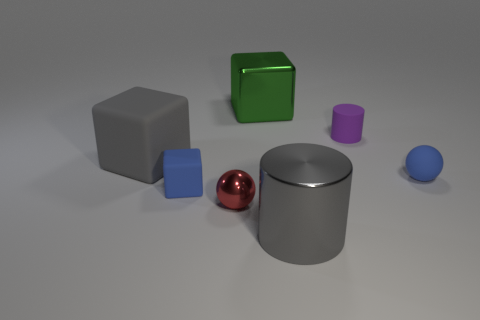Subtract all large metallic blocks. How many blocks are left? 2 Subtract all green cubes. How many cubes are left? 2 Subtract all balls. How many objects are left? 5 Add 1 brown matte cylinders. How many objects exist? 8 Subtract 1 blue spheres. How many objects are left? 6 Subtract all cyan balls. Subtract all yellow cubes. How many balls are left? 2 Subtract all blue balls. How many gray cylinders are left? 1 Subtract all red shiny spheres. Subtract all purple things. How many objects are left? 5 Add 3 large gray rubber cubes. How many large gray rubber cubes are left? 4 Add 7 small green matte blocks. How many small green matte blocks exist? 7 